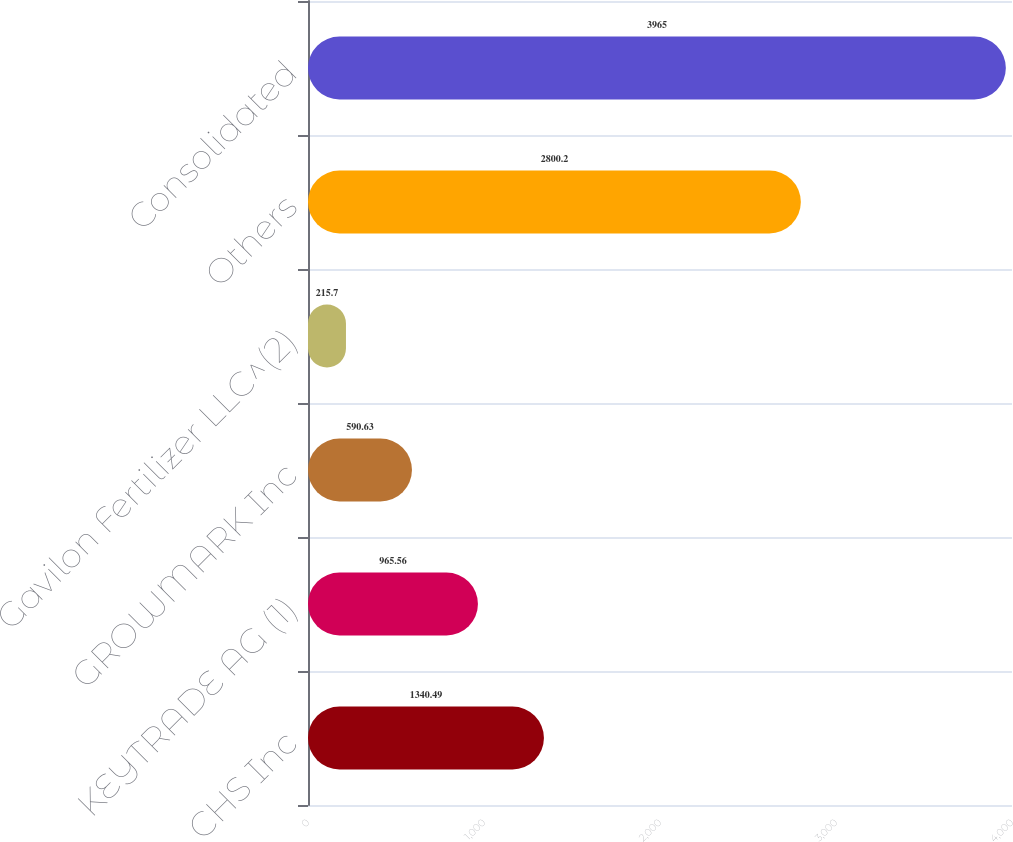Convert chart. <chart><loc_0><loc_0><loc_500><loc_500><bar_chart><fcel>CHS Inc<fcel>KEYTRADE AG (1)<fcel>GROWMARK Inc<fcel>Gavilon Fertilizer LLC^(2)<fcel>Others<fcel>Consolidated<nl><fcel>1340.49<fcel>965.56<fcel>590.63<fcel>215.7<fcel>2800.2<fcel>3965<nl></chart> 